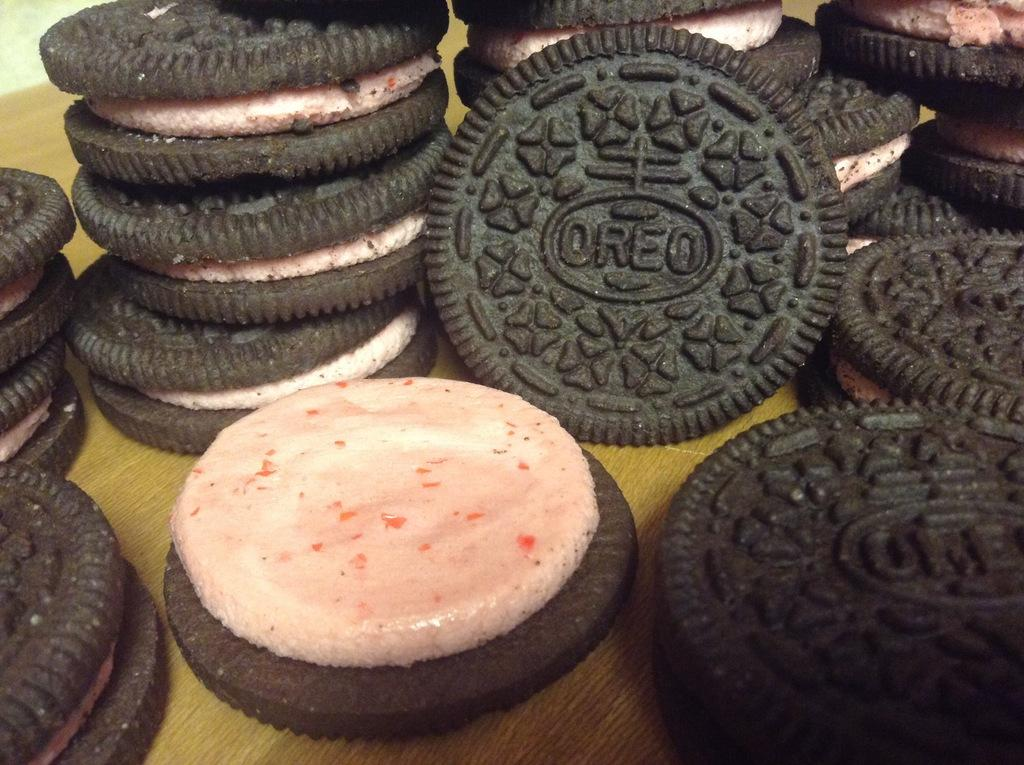What type of biscuits are in the image? There is a group of Oreo biscuits in the image. Where are the Oreo biscuits located? The Oreo biscuits are placed on a platform. What color is the coat that the Oreo biscuits are wearing in the image? There are no coats present in the image, as Oreo biscuits are not living beings and cannot wear clothing. 